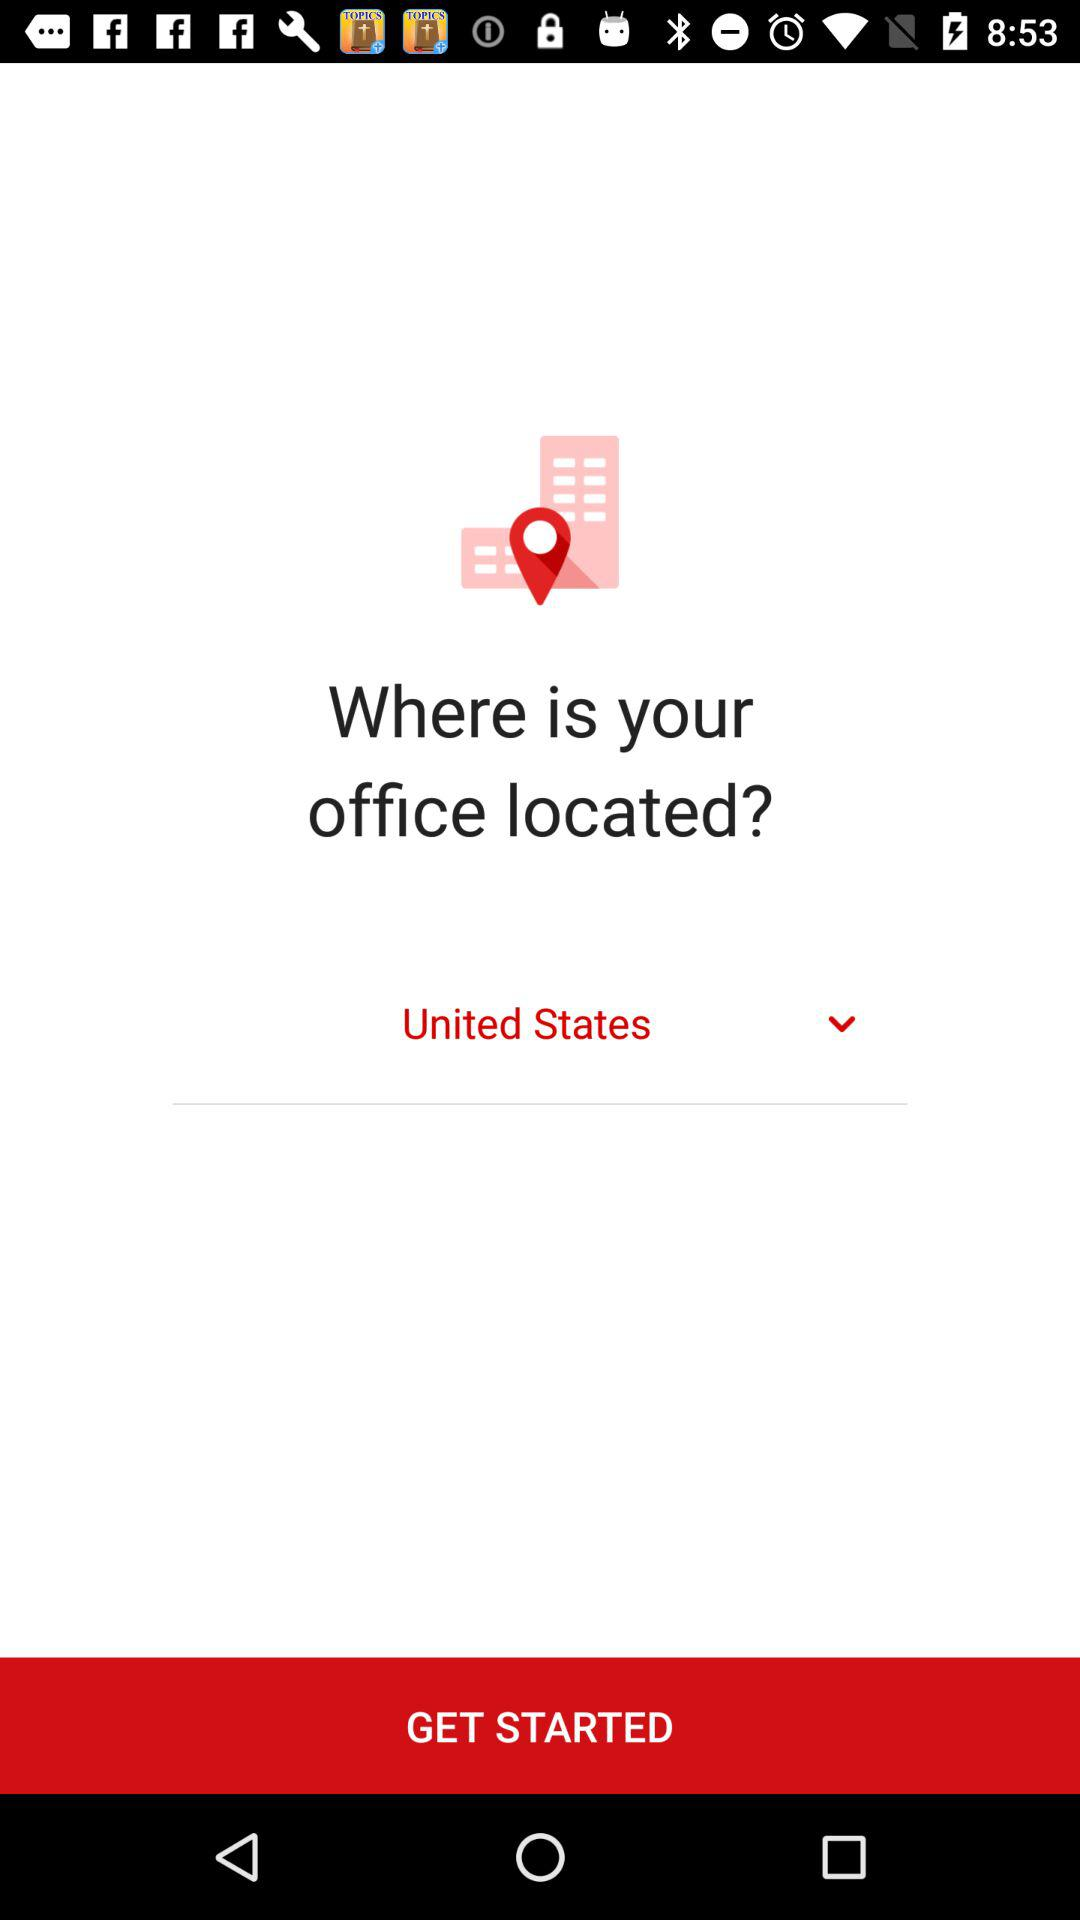Who is this application powered by?
When the provided information is insufficient, respond with <no answer>. <no answer> 